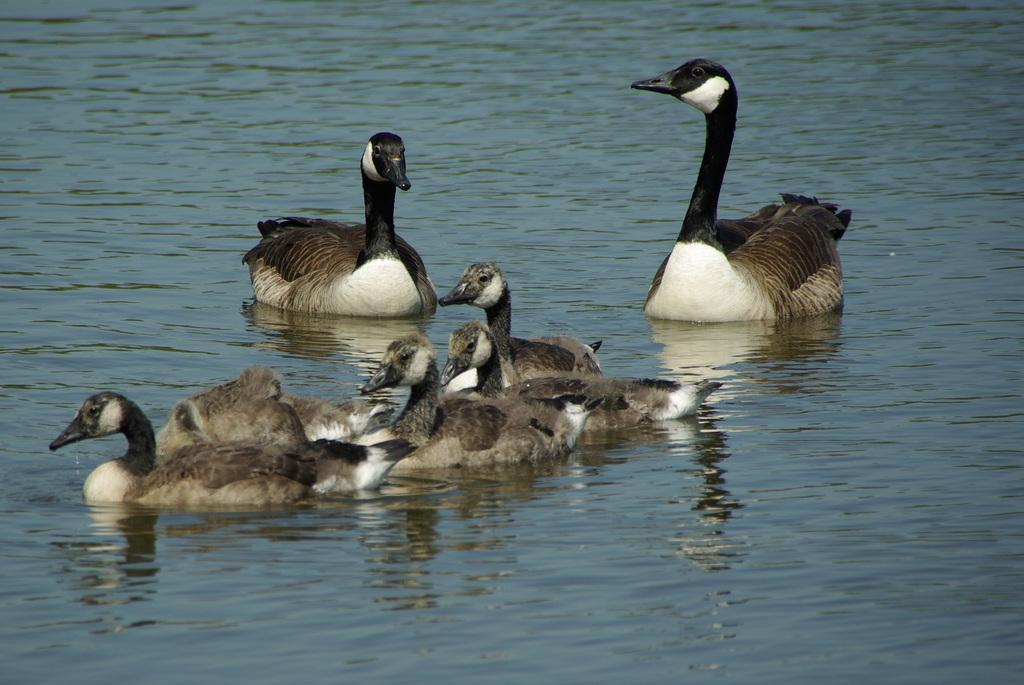What animals are present in the image? There are geese in the image. Where are the geese located? The geese are on the water. What can be observed about the geese's reflection in the water? The reflection of the geese is visible in the water. What type of thunder can be heard in the image? There is no thunder present in the image, as it features geese on the water. What role does the grandmother play in the image? There is no mention of a grandmother in the image, as it only features geese on the water. 